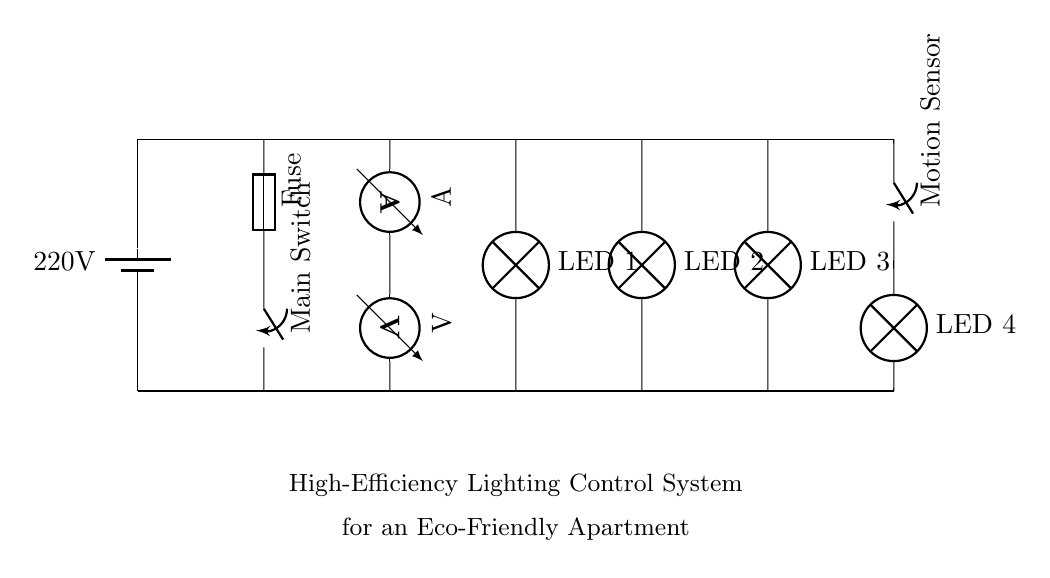What is the voltage in this circuit? The voltage in the circuit is 220 volts, as indicated by the battery symbol at the beginning of the circuit diagram.
Answer: 220 volts What type of lamps are used in this lighting control system? The circuit diagram shows four LED lamps, as labeled next to each lamp symbol.
Answer: LED What is the purpose of the fuse in this circuit? The fuse serves as a protective device that prevents excessive current flow, potentially safeguarding the circuit from damage.
Answer: Protection How many switches are present in the circuit? There are two switches in the circuit: the main switch and the motion sensor switch, both represented by switch symbols in the diagram.
Answer: Two What is the role of the motion sensor in this system? The motion sensor controls the operation of LED 4 based on detected motion, facilitating energy-efficient lighting by activating when needed.
Answer: Control What current measurement device is in the circuit? The circuit includes an ammeter, which is used to measure the current flowing through it, as represented by the ammeter symbol.
Answer: Ammeter How do the LED lamps connect to the power supply? The LED lamps are connected in parallel to the main power supply, allowing each lamp to operate independently despite the same voltage supply.
Answer: Parallel 